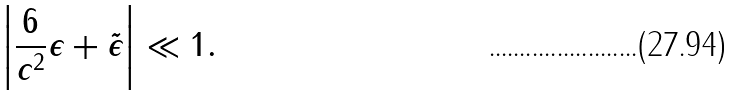<formula> <loc_0><loc_0><loc_500><loc_500>\left | \frac { 6 } { c ^ { 2 } } \epsilon + \tilde { \epsilon } \right | \ll 1 .</formula> 